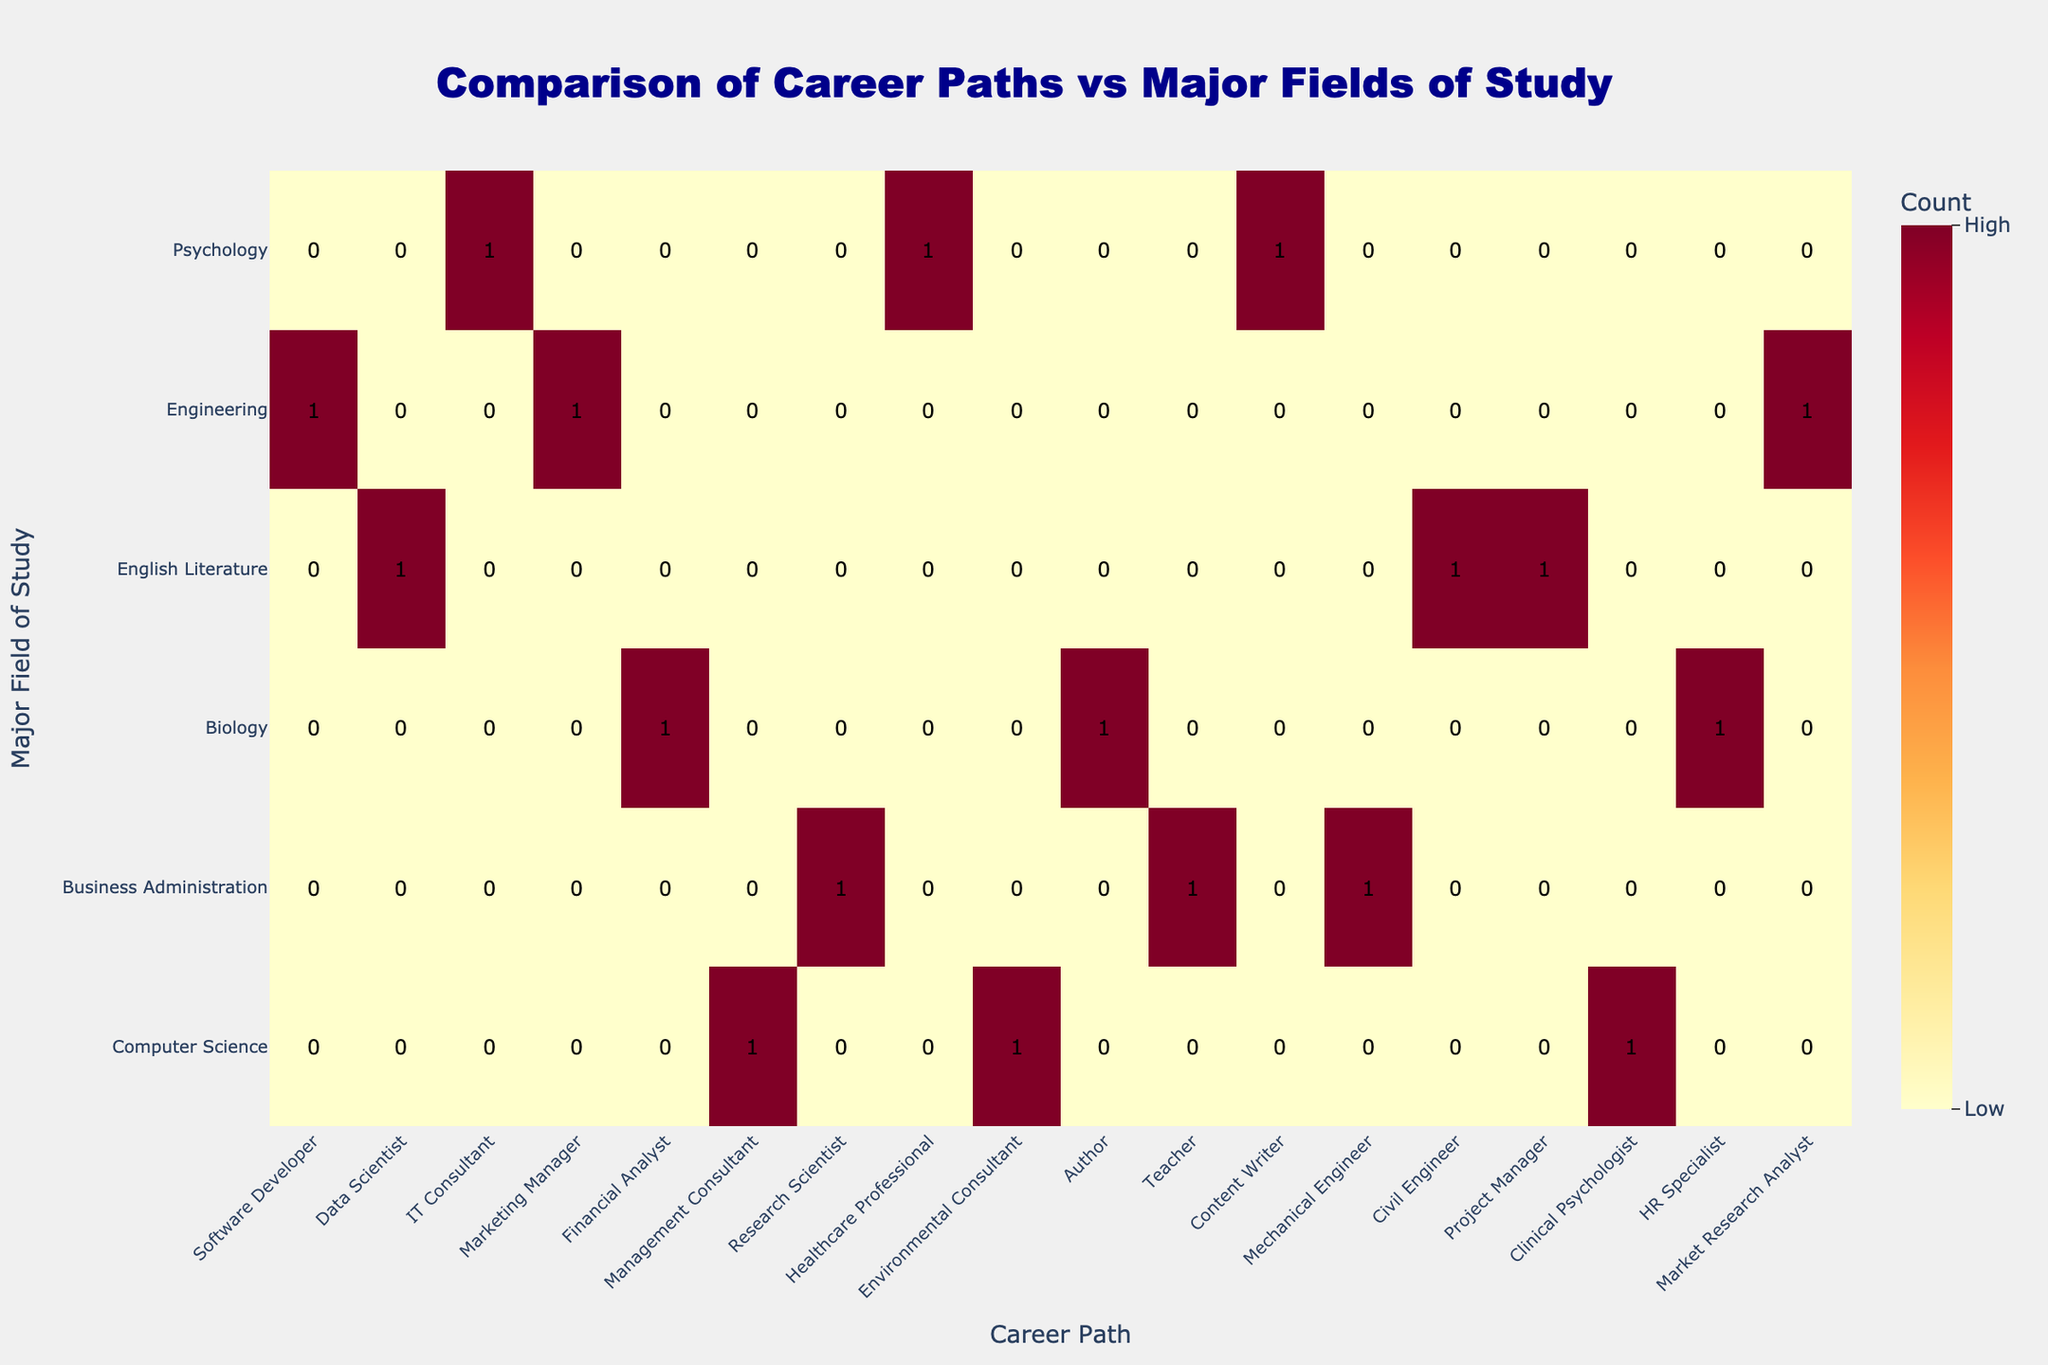What is the most common career path for graduates with a major in Computer Science? The table shows that the most common career path for graduates with a major in Computer Science is "Software Developer," as it has the highest count among the career paths listed for that major.
Answer: Software Developer How many different career paths are listed for graduates with a major in Biology? By counting the career paths under the Biology major, we see three distinct paths: Research Scientist, Healthcare Professional, and Environmental Consultant. Therefore, the total is three.
Answer: 3 Do graduates with a major in Engineering have more career paths than graduates with a major in English Literature? The Engineering major has three career paths (Mechanical Engineer, Civil Engineer, Project Manager), while the English Literature major has three paths as well (Author, Teacher, Content Writer). Therefore, they are equal.
Answer: No What is the total number of graduates from Business Administration and their associated career paths? The Business Administration major has three career paths: Marketing Manager, Financial Analyst, and Management Consultant. Adding the counts from these paths gives a total of three career paths for Business Administration graduates.
Answer: 3 Which major has the highest total number of career paths associated with it? By comparing the number of career paths for each major, we find that all the majors listed (Computer Science, Business Administration, Biology, English Literature, Engineering, and Psychology) have three paths, except Psychology, which also lists three paths, resulting in no major being higher.
Answer: None, they are equal How many graduates are likely to become a Healthcare Professional if they major in Biology? From the data, the count for the career path "Healthcare Professional" under the Biology major shows a total of one. Therefore, students majoring in Biology are likely to have one graduate targeting this career path.
Answer: 1 Which career paths have an equal number of graduates from engineering and psychology? Both the Engineering major (with 3 paths) and Psychology major (Clinical Psychologist, HR Specialist, Market Research Analyst) listed three career paths each. Therefore, there is equality in the number of paths for both majors.
Answer: Engineering and Psychology Based on the data, which major has the least diversity in career paths and what is the respective career path? Since all majors have three paths, we focus on any specific career paths. All majors seem to have similar diversity but looking at individual cases is necessary. Each major, including Computer Science and Business Administration, lists three diverse paths. So, no major has less diversity than others.
Answer: None, they're equal 